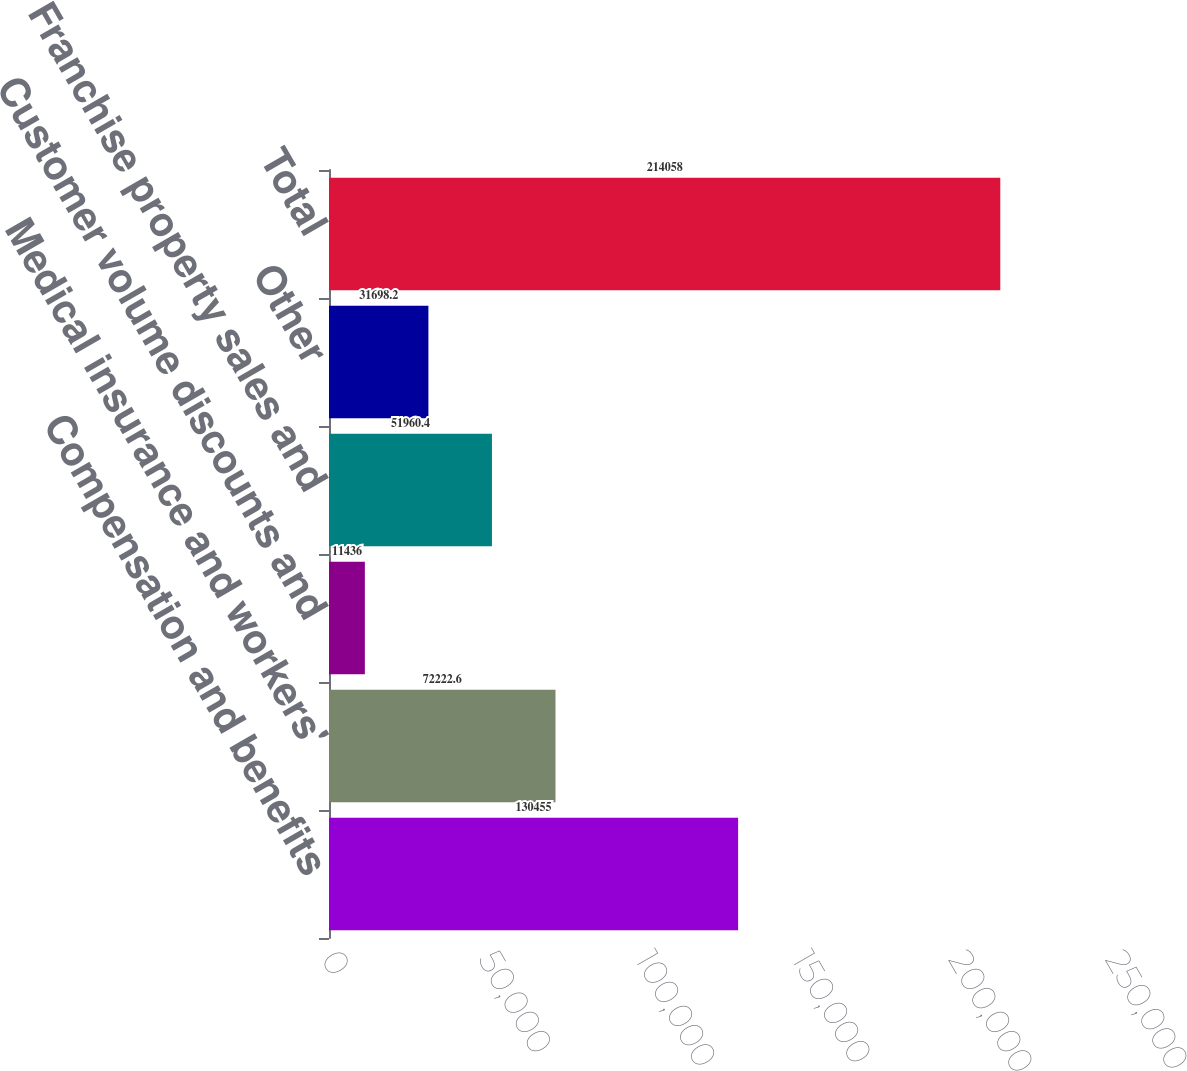<chart> <loc_0><loc_0><loc_500><loc_500><bar_chart><fcel>Compensation and benefits<fcel>Medical insurance and workers'<fcel>Customer volume discounts and<fcel>Franchise property sales and<fcel>Other<fcel>Total<nl><fcel>130455<fcel>72222.6<fcel>11436<fcel>51960.4<fcel>31698.2<fcel>214058<nl></chart> 